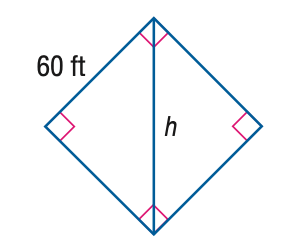Question: Find the value of h.
Choices:
A. 60
B. 84.85
C. 103.92
D. 120
Answer with the letter. Answer: B 